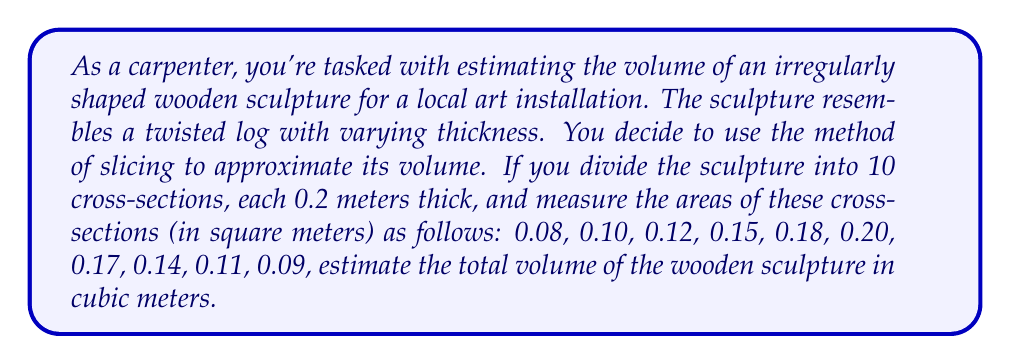Show me your answer to this math problem. To estimate the volume of this irregularly shaped wooden object, we'll use the method of slicing, which is a basic form of integration. This method is similar to Riemann sums in calculus, but we'll keep it simple for our carpentry needs.

1) First, let's recall the formula for the volume of a cylinder:
   $V = A \cdot h$
   where $A$ is the area of the base and $h$ is the height.

2) In our case, we're treating each slice as a small cylinder. The height of each slice is constant at 0.2 meters.

3) To approximate the total volume, we'll sum the volumes of all slices:

   $$V_{total} \approx \sum_{i=1}^{10} A_i \cdot 0.2$$

   where $A_i$ is the area of the $i$-th cross-section.

4) Let's calculate this sum:

   $$\begin{align*}
   V_{total} &\approx (0.08 + 0.10 + 0.12 + 0.15 + 0.18 + 0.20 + 0.17 + 0.14 + 0.11 + 0.09) \cdot 0.2 \\
   &= 1.34 \cdot 0.2 \\
   &= 0.268 \text{ m}^3
   \end{align*}$$

5) This method gives us an approximation of the volume. The accuracy could be improved by using more slices (i.e., making them thinner), but this level of precision is often sufficient for many carpentry tasks.
Answer: The estimated volume of the wooden sculpture is approximately 0.268 cubic meters. 